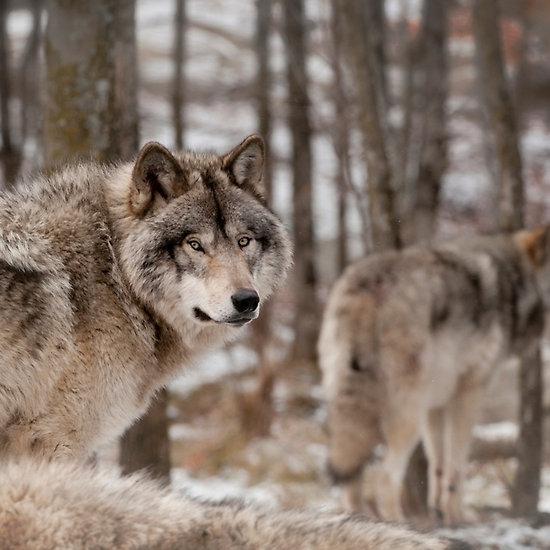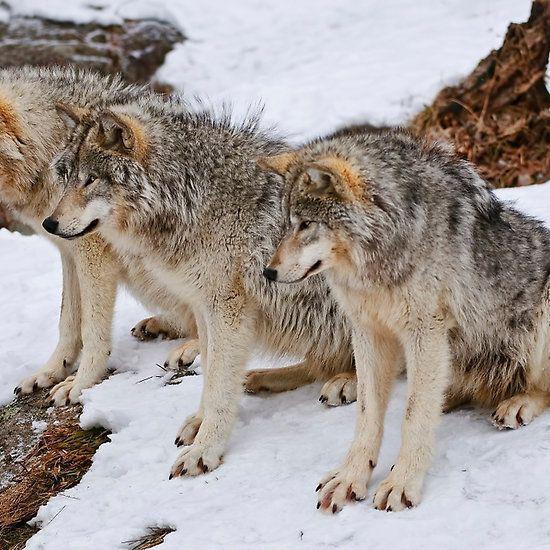The first image is the image on the left, the second image is the image on the right. For the images displayed, is the sentence "In total, no more than four wolves are visible." factually correct? Answer yes or no. No. The first image is the image on the left, the second image is the image on the right. Considering the images on both sides, is "There are at least five wolves." valid? Answer yes or no. Yes. 